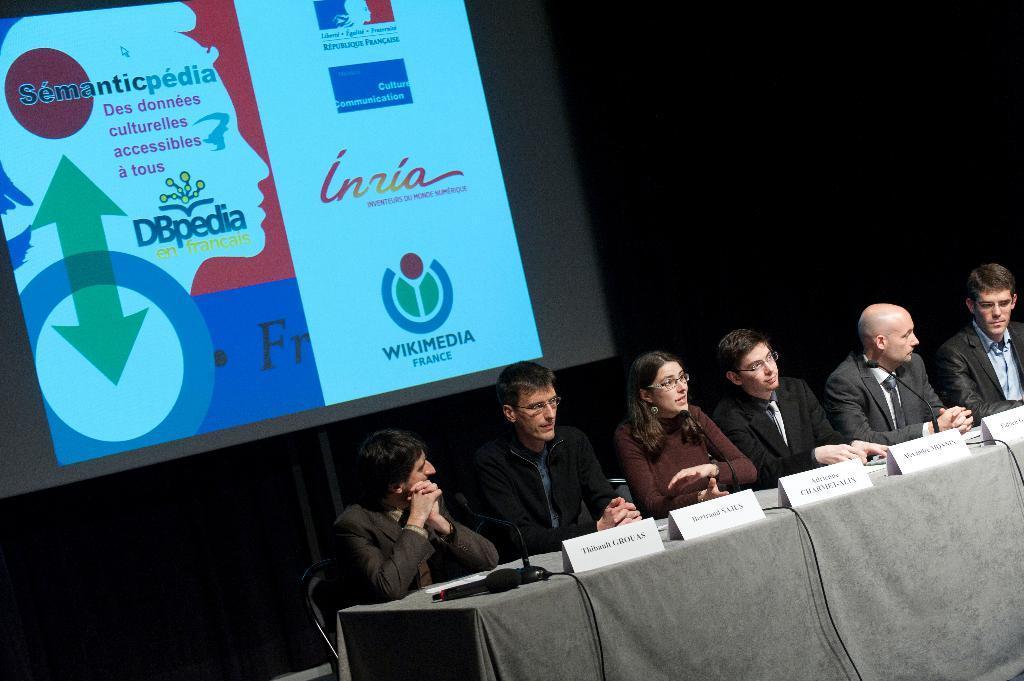Can you describe this image briefly? On the background we can see screen. We can see all the persons sitting on chairs in front of a table and on the table we can see name boards, mike's. 